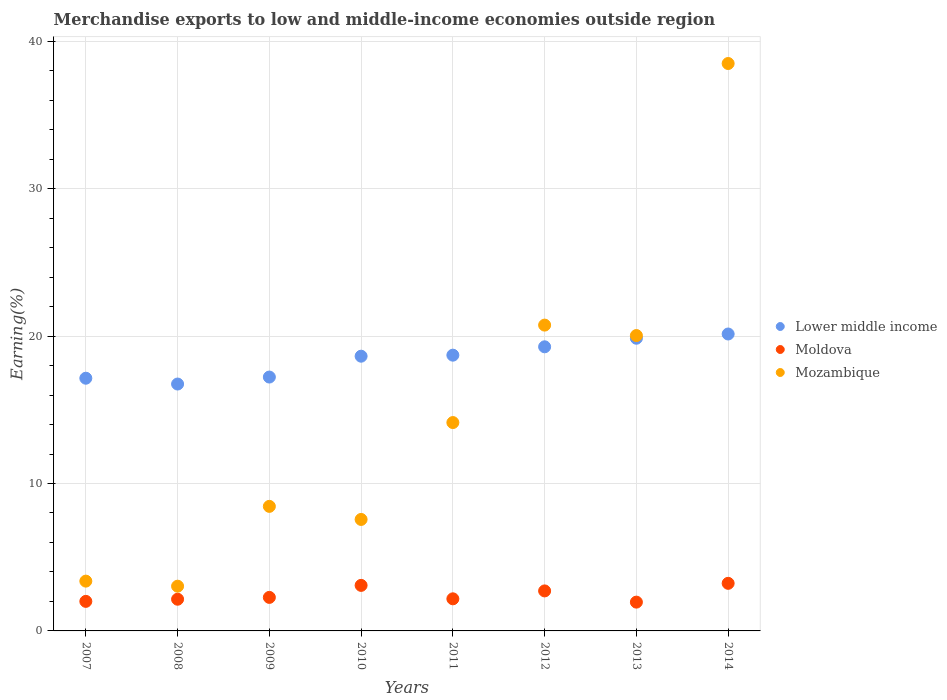How many different coloured dotlines are there?
Your response must be concise. 3. What is the percentage of amount earned from merchandise exports in Moldova in 2013?
Provide a short and direct response. 1.95. Across all years, what is the maximum percentage of amount earned from merchandise exports in Moldova?
Ensure brevity in your answer.  3.23. Across all years, what is the minimum percentage of amount earned from merchandise exports in Moldova?
Your answer should be compact. 1.95. In which year was the percentage of amount earned from merchandise exports in Moldova maximum?
Make the answer very short. 2014. In which year was the percentage of amount earned from merchandise exports in Moldova minimum?
Give a very brief answer. 2013. What is the total percentage of amount earned from merchandise exports in Lower middle income in the graph?
Your answer should be compact. 147.72. What is the difference between the percentage of amount earned from merchandise exports in Lower middle income in 2008 and that in 2014?
Your response must be concise. -3.39. What is the difference between the percentage of amount earned from merchandise exports in Mozambique in 2013 and the percentage of amount earned from merchandise exports in Moldova in 2008?
Provide a short and direct response. 17.89. What is the average percentage of amount earned from merchandise exports in Lower middle income per year?
Keep it short and to the point. 18.47. In the year 2014, what is the difference between the percentage of amount earned from merchandise exports in Lower middle income and percentage of amount earned from merchandise exports in Mozambique?
Make the answer very short. -18.35. In how many years, is the percentage of amount earned from merchandise exports in Lower middle income greater than 12 %?
Provide a short and direct response. 8. What is the ratio of the percentage of amount earned from merchandise exports in Moldova in 2007 to that in 2009?
Provide a short and direct response. 0.88. Is the difference between the percentage of amount earned from merchandise exports in Lower middle income in 2012 and 2013 greater than the difference between the percentage of amount earned from merchandise exports in Mozambique in 2012 and 2013?
Make the answer very short. No. What is the difference between the highest and the second highest percentage of amount earned from merchandise exports in Lower middle income?
Your response must be concise. 0.29. What is the difference between the highest and the lowest percentage of amount earned from merchandise exports in Mozambique?
Keep it short and to the point. 35.46. In how many years, is the percentage of amount earned from merchandise exports in Lower middle income greater than the average percentage of amount earned from merchandise exports in Lower middle income taken over all years?
Your answer should be compact. 5. Does the percentage of amount earned from merchandise exports in Mozambique monotonically increase over the years?
Make the answer very short. No. Is the percentage of amount earned from merchandise exports in Mozambique strictly greater than the percentage of amount earned from merchandise exports in Moldova over the years?
Keep it short and to the point. Yes. Is the percentage of amount earned from merchandise exports in Lower middle income strictly less than the percentage of amount earned from merchandise exports in Moldova over the years?
Provide a succinct answer. No. How many years are there in the graph?
Provide a succinct answer. 8. What is the difference between two consecutive major ticks on the Y-axis?
Your response must be concise. 10. Where does the legend appear in the graph?
Offer a very short reply. Center right. How are the legend labels stacked?
Keep it short and to the point. Vertical. What is the title of the graph?
Give a very brief answer. Merchandise exports to low and middle-income economies outside region. Does "Latin America(all income levels)" appear as one of the legend labels in the graph?
Give a very brief answer. No. What is the label or title of the Y-axis?
Offer a terse response. Earning(%). What is the Earning(%) of Lower middle income in 2007?
Your answer should be very brief. 17.14. What is the Earning(%) in Moldova in 2007?
Offer a very short reply. 2. What is the Earning(%) of Mozambique in 2007?
Your response must be concise. 3.38. What is the Earning(%) of Lower middle income in 2008?
Offer a very short reply. 16.75. What is the Earning(%) in Moldova in 2008?
Your response must be concise. 2.15. What is the Earning(%) of Mozambique in 2008?
Your response must be concise. 3.03. What is the Earning(%) of Lower middle income in 2009?
Make the answer very short. 17.22. What is the Earning(%) in Moldova in 2009?
Give a very brief answer. 2.27. What is the Earning(%) in Mozambique in 2009?
Your answer should be very brief. 8.45. What is the Earning(%) in Lower middle income in 2010?
Provide a short and direct response. 18.64. What is the Earning(%) of Moldova in 2010?
Your answer should be very brief. 3.09. What is the Earning(%) of Mozambique in 2010?
Offer a terse response. 7.56. What is the Earning(%) in Lower middle income in 2011?
Ensure brevity in your answer.  18.71. What is the Earning(%) of Moldova in 2011?
Your response must be concise. 2.18. What is the Earning(%) in Mozambique in 2011?
Ensure brevity in your answer.  14.13. What is the Earning(%) of Lower middle income in 2012?
Your answer should be very brief. 19.27. What is the Earning(%) in Moldova in 2012?
Make the answer very short. 2.71. What is the Earning(%) in Mozambique in 2012?
Provide a short and direct response. 20.74. What is the Earning(%) of Lower middle income in 2013?
Keep it short and to the point. 19.85. What is the Earning(%) of Moldova in 2013?
Give a very brief answer. 1.95. What is the Earning(%) of Mozambique in 2013?
Your answer should be very brief. 20.04. What is the Earning(%) of Lower middle income in 2014?
Your answer should be compact. 20.14. What is the Earning(%) in Moldova in 2014?
Give a very brief answer. 3.23. What is the Earning(%) in Mozambique in 2014?
Offer a very short reply. 38.49. Across all years, what is the maximum Earning(%) in Lower middle income?
Your response must be concise. 20.14. Across all years, what is the maximum Earning(%) of Moldova?
Provide a short and direct response. 3.23. Across all years, what is the maximum Earning(%) of Mozambique?
Give a very brief answer. 38.49. Across all years, what is the minimum Earning(%) of Lower middle income?
Your answer should be compact. 16.75. Across all years, what is the minimum Earning(%) of Moldova?
Provide a succinct answer. 1.95. Across all years, what is the minimum Earning(%) in Mozambique?
Make the answer very short. 3.03. What is the total Earning(%) of Lower middle income in the graph?
Your answer should be very brief. 147.72. What is the total Earning(%) of Moldova in the graph?
Your answer should be compact. 19.59. What is the total Earning(%) in Mozambique in the graph?
Offer a very short reply. 115.83. What is the difference between the Earning(%) of Lower middle income in 2007 and that in 2008?
Give a very brief answer. 0.39. What is the difference between the Earning(%) of Moldova in 2007 and that in 2008?
Offer a very short reply. -0.15. What is the difference between the Earning(%) in Mozambique in 2007 and that in 2008?
Provide a succinct answer. 0.34. What is the difference between the Earning(%) in Lower middle income in 2007 and that in 2009?
Offer a very short reply. -0.08. What is the difference between the Earning(%) of Moldova in 2007 and that in 2009?
Your response must be concise. -0.27. What is the difference between the Earning(%) of Mozambique in 2007 and that in 2009?
Make the answer very short. -5.07. What is the difference between the Earning(%) in Lower middle income in 2007 and that in 2010?
Keep it short and to the point. -1.49. What is the difference between the Earning(%) in Moldova in 2007 and that in 2010?
Ensure brevity in your answer.  -1.08. What is the difference between the Earning(%) in Mozambique in 2007 and that in 2010?
Your answer should be very brief. -4.18. What is the difference between the Earning(%) in Lower middle income in 2007 and that in 2011?
Provide a short and direct response. -1.56. What is the difference between the Earning(%) in Moldova in 2007 and that in 2011?
Ensure brevity in your answer.  -0.17. What is the difference between the Earning(%) of Mozambique in 2007 and that in 2011?
Provide a short and direct response. -10.76. What is the difference between the Earning(%) in Lower middle income in 2007 and that in 2012?
Your response must be concise. -2.13. What is the difference between the Earning(%) of Moldova in 2007 and that in 2012?
Keep it short and to the point. -0.71. What is the difference between the Earning(%) of Mozambique in 2007 and that in 2012?
Provide a short and direct response. -17.37. What is the difference between the Earning(%) of Lower middle income in 2007 and that in 2013?
Make the answer very short. -2.71. What is the difference between the Earning(%) of Moldova in 2007 and that in 2013?
Your response must be concise. 0.05. What is the difference between the Earning(%) of Mozambique in 2007 and that in 2013?
Offer a terse response. -16.66. What is the difference between the Earning(%) of Lower middle income in 2007 and that in 2014?
Keep it short and to the point. -3. What is the difference between the Earning(%) in Moldova in 2007 and that in 2014?
Provide a short and direct response. -1.22. What is the difference between the Earning(%) in Mozambique in 2007 and that in 2014?
Make the answer very short. -35.11. What is the difference between the Earning(%) in Lower middle income in 2008 and that in 2009?
Your answer should be very brief. -0.47. What is the difference between the Earning(%) in Moldova in 2008 and that in 2009?
Give a very brief answer. -0.12. What is the difference between the Earning(%) of Mozambique in 2008 and that in 2009?
Give a very brief answer. -5.41. What is the difference between the Earning(%) of Lower middle income in 2008 and that in 2010?
Provide a succinct answer. -1.89. What is the difference between the Earning(%) in Moldova in 2008 and that in 2010?
Keep it short and to the point. -0.94. What is the difference between the Earning(%) of Mozambique in 2008 and that in 2010?
Offer a very short reply. -4.53. What is the difference between the Earning(%) of Lower middle income in 2008 and that in 2011?
Your answer should be very brief. -1.96. What is the difference between the Earning(%) of Moldova in 2008 and that in 2011?
Keep it short and to the point. -0.03. What is the difference between the Earning(%) of Mozambique in 2008 and that in 2011?
Offer a terse response. -11.1. What is the difference between the Earning(%) of Lower middle income in 2008 and that in 2012?
Your answer should be very brief. -2.53. What is the difference between the Earning(%) of Moldova in 2008 and that in 2012?
Offer a very short reply. -0.56. What is the difference between the Earning(%) of Mozambique in 2008 and that in 2012?
Ensure brevity in your answer.  -17.71. What is the difference between the Earning(%) in Lower middle income in 2008 and that in 2013?
Your response must be concise. -3.11. What is the difference between the Earning(%) in Moldova in 2008 and that in 2013?
Provide a short and direct response. 0.2. What is the difference between the Earning(%) in Mozambique in 2008 and that in 2013?
Provide a succinct answer. -17. What is the difference between the Earning(%) in Lower middle income in 2008 and that in 2014?
Provide a succinct answer. -3.39. What is the difference between the Earning(%) in Moldova in 2008 and that in 2014?
Your answer should be very brief. -1.08. What is the difference between the Earning(%) of Mozambique in 2008 and that in 2014?
Your answer should be very brief. -35.46. What is the difference between the Earning(%) of Lower middle income in 2009 and that in 2010?
Your answer should be compact. -1.41. What is the difference between the Earning(%) in Moldova in 2009 and that in 2010?
Your answer should be compact. -0.81. What is the difference between the Earning(%) in Mozambique in 2009 and that in 2010?
Your answer should be compact. 0.89. What is the difference between the Earning(%) of Lower middle income in 2009 and that in 2011?
Make the answer very short. -1.48. What is the difference between the Earning(%) of Moldova in 2009 and that in 2011?
Provide a succinct answer. 0.1. What is the difference between the Earning(%) of Mozambique in 2009 and that in 2011?
Keep it short and to the point. -5.69. What is the difference between the Earning(%) in Lower middle income in 2009 and that in 2012?
Provide a short and direct response. -2.05. What is the difference between the Earning(%) of Moldova in 2009 and that in 2012?
Ensure brevity in your answer.  -0.44. What is the difference between the Earning(%) in Mozambique in 2009 and that in 2012?
Offer a very short reply. -12.3. What is the difference between the Earning(%) of Lower middle income in 2009 and that in 2013?
Your answer should be compact. -2.63. What is the difference between the Earning(%) of Moldova in 2009 and that in 2013?
Give a very brief answer. 0.32. What is the difference between the Earning(%) of Mozambique in 2009 and that in 2013?
Keep it short and to the point. -11.59. What is the difference between the Earning(%) in Lower middle income in 2009 and that in 2014?
Make the answer very short. -2.92. What is the difference between the Earning(%) in Moldova in 2009 and that in 2014?
Your answer should be compact. -0.95. What is the difference between the Earning(%) of Mozambique in 2009 and that in 2014?
Provide a succinct answer. -30.04. What is the difference between the Earning(%) in Lower middle income in 2010 and that in 2011?
Provide a short and direct response. -0.07. What is the difference between the Earning(%) in Moldova in 2010 and that in 2011?
Offer a very short reply. 0.91. What is the difference between the Earning(%) in Mozambique in 2010 and that in 2011?
Provide a succinct answer. -6.57. What is the difference between the Earning(%) of Lower middle income in 2010 and that in 2012?
Offer a very short reply. -0.64. What is the difference between the Earning(%) of Mozambique in 2010 and that in 2012?
Keep it short and to the point. -13.18. What is the difference between the Earning(%) in Lower middle income in 2010 and that in 2013?
Offer a very short reply. -1.22. What is the difference between the Earning(%) in Moldova in 2010 and that in 2013?
Give a very brief answer. 1.14. What is the difference between the Earning(%) of Mozambique in 2010 and that in 2013?
Make the answer very short. -12.47. What is the difference between the Earning(%) in Lower middle income in 2010 and that in 2014?
Your response must be concise. -1.51. What is the difference between the Earning(%) in Moldova in 2010 and that in 2014?
Keep it short and to the point. -0.14. What is the difference between the Earning(%) of Mozambique in 2010 and that in 2014?
Offer a very short reply. -30.93. What is the difference between the Earning(%) of Lower middle income in 2011 and that in 2012?
Offer a very short reply. -0.57. What is the difference between the Earning(%) of Moldova in 2011 and that in 2012?
Offer a very short reply. -0.54. What is the difference between the Earning(%) in Mozambique in 2011 and that in 2012?
Your response must be concise. -6.61. What is the difference between the Earning(%) of Lower middle income in 2011 and that in 2013?
Ensure brevity in your answer.  -1.15. What is the difference between the Earning(%) of Moldova in 2011 and that in 2013?
Offer a very short reply. 0.22. What is the difference between the Earning(%) of Mozambique in 2011 and that in 2013?
Your response must be concise. -5.9. What is the difference between the Earning(%) in Lower middle income in 2011 and that in 2014?
Offer a terse response. -1.44. What is the difference between the Earning(%) of Moldova in 2011 and that in 2014?
Your answer should be compact. -1.05. What is the difference between the Earning(%) of Mozambique in 2011 and that in 2014?
Offer a very short reply. -24.36. What is the difference between the Earning(%) in Lower middle income in 2012 and that in 2013?
Your answer should be compact. -0.58. What is the difference between the Earning(%) of Moldova in 2012 and that in 2013?
Offer a terse response. 0.76. What is the difference between the Earning(%) in Mozambique in 2012 and that in 2013?
Your response must be concise. 0.71. What is the difference between the Earning(%) of Lower middle income in 2012 and that in 2014?
Make the answer very short. -0.87. What is the difference between the Earning(%) in Moldova in 2012 and that in 2014?
Provide a short and direct response. -0.51. What is the difference between the Earning(%) in Mozambique in 2012 and that in 2014?
Offer a very short reply. -17.75. What is the difference between the Earning(%) of Lower middle income in 2013 and that in 2014?
Provide a short and direct response. -0.29. What is the difference between the Earning(%) in Moldova in 2013 and that in 2014?
Make the answer very short. -1.28. What is the difference between the Earning(%) in Mozambique in 2013 and that in 2014?
Provide a short and direct response. -18.45. What is the difference between the Earning(%) in Lower middle income in 2007 and the Earning(%) in Moldova in 2008?
Keep it short and to the point. 14.99. What is the difference between the Earning(%) of Lower middle income in 2007 and the Earning(%) of Mozambique in 2008?
Offer a very short reply. 14.11. What is the difference between the Earning(%) in Moldova in 2007 and the Earning(%) in Mozambique in 2008?
Make the answer very short. -1.03. What is the difference between the Earning(%) in Lower middle income in 2007 and the Earning(%) in Moldova in 2009?
Your answer should be compact. 14.87. What is the difference between the Earning(%) of Lower middle income in 2007 and the Earning(%) of Mozambique in 2009?
Keep it short and to the point. 8.69. What is the difference between the Earning(%) in Moldova in 2007 and the Earning(%) in Mozambique in 2009?
Your answer should be very brief. -6.44. What is the difference between the Earning(%) of Lower middle income in 2007 and the Earning(%) of Moldova in 2010?
Offer a terse response. 14.05. What is the difference between the Earning(%) of Lower middle income in 2007 and the Earning(%) of Mozambique in 2010?
Your response must be concise. 9.58. What is the difference between the Earning(%) in Moldova in 2007 and the Earning(%) in Mozambique in 2010?
Provide a succinct answer. -5.56. What is the difference between the Earning(%) of Lower middle income in 2007 and the Earning(%) of Moldova in 2011?
Give a very brief answer. 14.96. What is the difference between the Earning(%) of Lower middle income in 2007 and the Earning(%) of Mozambique in 2011?
Offer a very short reply. 3.01. What is the difference between the Earning(%) of Moldova in 2007 and the Earning(%) of Mozambique in 2011?
Give a very brief answer. -12.13. What is the difference between the Earning(%) in Lower middle income in 2007 and the Earning(%) in Moldova in 2012?
Provide a succinct answer. 14.43. What is the difference between the Earning(%) in Lower middle income in 2007 and the Earning(%) in Mozambique in 2012?
Offer a very short reply. -3.6. What is the difference between the Earning(%) in Moldova in 2007 and the Earning(%) in Mozambique in 2012?
Your answer should be compact. -18.74. What is the difference between the Earning(%) of Lower middle income in 2007 and the Earning(%) of Moldova in 2013?
Provide a short and direct response. 15.19. What is the difference between the Earning(%) in Lower middle income in 2007 and the Earning(%) in Mozambique in 2013?
Your response must be concise. -2.89. What is the difference between the Earning(%) in Moldova in 2007 and the Earning(%) in Mozambique in 2013?
Offer a terse response. -18.03. What is the difference between the Earning(%) in Lower middle income in 2007 and the Earning(%) in Moldova in 2014?
Keep it short and to the point. 13.91. What is the difference between the Earning(%) of Lower middle income in 2007 and the Earning(%) of Mozambique in 2014?
Your response must be concise. -21.35. What is the difference between the Earning(%) of Moldova in 2007 and the Earning(%) of Mozambique in 2014?
Your answer should be very brief. -36.49. What is the difference between the Earning(%) of Lower middle income in 2008 and the Earning(%) of Moldova in 2009?
Offer a very short reply. 14.47. What is the difference between the Earning(%) of Lower middle income in 2008 and the Earning(%) of Mozambique in 2009?
Give a very brief answer. 8.3. What is the difference between the Earning(%) in Moldova in 2008 and the Earning(%) in Mozambique in 2009?
Provide a short and direct response. -6.3. What is the difference between the Earning(%) in Lower middle income in 2008 and the Earning(%) in Moldova in 2010?
Keep it short and to the point. 13.66. What is the difference between the Earning(%) in Lower middle income in 2008 and the Earning(%) in Mozambique in 2010?
Your response must be concise. 9.19. What is the difference between the Earning(%) in Moldova in 2008 and the Earning(%) in Mozambique in 2010?
Give a very brief answer. -5.41. What is the difference between the Earning(%) of Lower middle income in 2008 and the Earning(%) of Moldova in 2011?
Offer a very short reply. 14.57. What is the difference between the Earning(%) in Lower middle income in 2008 and the Earning(%) in Mozambique in 2011?
Provide a short and direct response. 2.61. What is the difference between the Earning(%) of Moldova in 2008 and the Earning(%) of Mozambique in 2011?
Your answer should be very brief. -11.98. What is the difference between the Earning(%) in Lower middle income in 2008 and the Earning(%) in Moldova in 2012?
Make the answer very short. 14.03. What is the difference between the Earning(%) of Lower middle income in 2008 and the Earning(%) of Mozambique in 2012?
Provide a short and direct response. -4. What is the difference between the Earning(%) of Moldova in 2008 and the Earning(%) of Mozambique in 2012?
Your answer should be compact. -18.59. What is the difference between the Earning(%) in Lower middle income in 2008 and the Earning(%) in Moldova in 2013?
Your answer should be very brief. 14.79. What is the difference between the Earning(%) in Lower middle income in 2008 and the Earning(%) in Mozambique in 2013?
Ensure brevity in your answer.  -3.29. What is the difference between the Earning(%) in Moldova in 2008 and the Earning(%) in Mozambique in 2013?
Your answer should be compact. -17.89. What is the difference between the Earning(%) of Lower middle income in 2008 and the Earning(%) of Moldova in 2014?
Your answer should be compact. 13.52. What is the difference between the Earning(%) in Lower middle income in 2008 and the Earning(%) in Mozambique in 2014?
Give a very brief answer. -21.74. What is the difference between the Earning(%) in Moldova in 2008 and the Earning(%) in Mozambique in 2014?
Keep it short and to the point. -36.34. What is the difference between the Earning(%) in Lower middle income in 2009 and the Earning(%) in Moldova in 2010?
Make the answer very short. 14.13. What is the difference between the Earning(%) of Lower middle income in 2009 and the Earning(%) of Mozambique in 2010?
Offer a terse response. 9.66. What is the difference between the Earning(%) of Moldova in 2009 and the Earning(%) of Mozambique in 2010?
Your answer should be compact. -5.29. What is the difference between the Earning(%) of Lower middle income in 2009 and the Earning(%) of Moldova in 2011?
Your answer should be very brief. 15.04. What is the difference between the Earning(%) in Lower middle income in 2009 and the Earning(%) in Mozambique in 2011?
Give a very brief answer. 3.09. What is the difference between the Earning(%) in Moldova in 2009 and the Earning(%) in Mozambique in 2011?
Your answer should be compact. -11.86. What is the difference between the Earning(%) in Lower middle income in 2009 and the Earning(%) in Moldova in 2012?
Offer a terse response. 14.51. What is the difference between the Earning(%) of Lower middle income in 2009 and the Earning(%) of Mozambique in 2012?
Your answer should be compact. -3.52. What is the difference between the Earning(%) of Moldova in 2009 and the Earning(%) of Mozambique in 2012?
Give a very brief answer. -18.47. What is the difference between the Earning(%) of Lower middle income in 2009 and the Earning(%) of Moldova in 2013?
Your answer should be very brief. 15.27. What is the difference between the Earning(%) in Lower middle income in 2009 and the Earning(%) in Mozambique in 2013?
Ensure brevity in your answer.  -2.82. What is the difference between the Earning(%) in Moldova in 2009 and the Earning(%) in Mozambique in 2013?
Keep it short and to the point. -17.76. What is the difference between the Earning(%) of Lower middle income in 2009 and the Earning(%) of Moldova in 2014?
Ensure brevity in your answer.  13.99. What is the difference between the Earning(%) of Lower middle income in 2009 and the Earning(%) of Mozambique in 2014?
Give a very brief answer. -21.27. What is the difference between the Earning(%) of Moldova in 2009 and the Earning(%) of Mozambique in 2014?
Offer a terse response. -36.22. What is the difference between the Earning(%) in Lower middle income in 2010 and the Earning(%) in Moldova in 2011?
Offer a very short reply. 16.46. What is the difference between the Earning(%) of Lower middle income in 2010 and the Earning(%) of Mozambique in 2011?
Provide a succinct answer. 4.5. What is the difference between the Earning(%) of Moldova in 2010 and the Earning(%) of Mozambique in 2011?
Your response must be concise. -11.05. What is the difference between the Earning(%) of Lower middle income in 2010 and the Earning(%) of Moldova in 2012?
Provide a succinct answer. 15.92. What is the difference between the Earning(%) in Lower middle income in 2010 and the Earning(%) in Mozambique in 2012?
Ensure brevity in your answer.  -2.11. What is the difference between the Earning(%) of Moldova in 2010 and the Earning(%) of Mozambique in 2012?
Your response must be concise. -17.66. What is the difference between the Earning(%) in Lower middle income in 2010 and the Earning(%) in Moldova in 2013?
Provide a short and direct response. 16.68. What is the difference between the Earning(%) of Lower middle income in 2010 and the Earning(%) of Mozambique in 2013?
Provide a succinct answer. -1.4. What is the difference between the Earning(%) in Moldova in 2010 and the Earning(%) in Mozambique in 2013?
Offer a terse response. -16.95. What is the difference between the Earning(%) in Lower middle income in 2010 and the Earning(%) in Moldova in 2014?
Your answer should be very brief. 15.41. What is the difference between the Earning(%) of Lower middle income in 2010 and the Earning(%) of Mozambique in 2014?
Offer a very short reply. -19.85. What is the difference between the Earning(%) in Moldova in 2010 and the Earning(%) in Mozambique in 2014?
Provide a succinct answer. -35.4. What is the difference between the Earning(%) in Lower middle income in 2011 and the Earning(%) in Moldova in 2012?
Provide a short and direct response. 15.99. What is the difference between the Earning(%) of Lower middle income in 2011 and the Earning(%) of Mozambique in 2012?
Your answer should be compact. -2.04. What is the difference between the Earning(%) in Moldova in 2011 and the Earning(%) in Mozambique in 2012?
Your answer should be very brief. -18.57. What is the difference between the Earning(%) of Lower middle income in 2011 and the Earning(%) of Moldova in 2013?
Offer a very short reply. 16.75. What is the difference between the Earning(%) of Lower middle income in 2011 and the Earning(%) of Mozambique in 2013?
Provide a succinct answer. -1.33. What is the difference between the Earning(%) of Moldova in 2011 and the Earning(%) of Mozambique in 2013?
Offer a very short reply. -17.86. What is the difference between the Earning(%) of Lower middle income in 2011 and the Earning(%) of Moldova in 2014?
Give a very brief answer. 15.48. What is the difference between the Earning(%) of Lower middle income in 2011 and the Earning(%) of Mozambique in 2014?
Offer a terse response. -19.78. What is the difference between the Earning(%) in Moldova in 2011 and the Earning(%) in Mozambique in 2014?
Make the answer very short. -36.31. What is the difference between the Earning(%) in Lower middle income in 2012 and the Earning(%) in Moldova in 2013?
Keep it short and to the point. 17.32. What is the difference between the Earning(%) in Lower middle income in 2012 and the Earning(%) in Mozambique in 2013?
Your answer should be compact. -0.76. What is the difference between the Earning(%) in Moldova in 2012 and the Earning(%) in Mozambique in 2013?
Offer a terse response. -17.32. What is the difference between the Earning(%) in Lower middle income in 2012 and the Earning(%) in Moldova in 2014?
Offer a very short reply. 16.04. What is the difference between the Earning(%) in Lower middle income in 2012 and the Earning(%) in Mozambique in 2014?
Give a very brief answer. -19.22. What is the difference between the Earning(%) of Moldova in 2012 and the Earning(%) of Mozambique in 2014?
Provide a succinct answer. -35.78. What is the difference between the Earning(%) of Lower middle income in 2013 and the Earning(%) of Moldova in 2014?
Your answer should be very brief. 16.63. What is the difference between the Earning(%) of Lower middle income in 2013 and the Earning(%) of Mozambique in 2014?
Give a very brief answer. -18.64. What is the difference between the Earning(%) of Moldova in 2013 and the Earning(%) of Mozambique in 2014?
Keep it short and to the point. -36.54. What is the average Earning(%) in Lower middle income per year?
Your response must be concise. 18.47. What is the average Earning(%) of Moldova per year?
Provide a succinct answer. 2.45. What is the average Earning(%) of Mozambique per year?
Your answer should be compact. 14.48. In the year 2007, what is the difference between the Earning(%) in Lower middle income and Earning(%) in Moldova?
Make the answer very short. 15.14. In the year 2007, what is the difference between the Earning(%) in Lower middle income and Earning(%) in Mozambique?
Keep it short and to the point. 13.76. In the year 2007, what is the difference between the Earning(%) in Moldova and Earning(%) in Mozambique?
Ensure brevity in your answer.  -1.37. In the year 2008, what is the difference between the Earning(%) in Lower middle income and Earning(%) in Moldova?
Offer a very short reply. 14.6. In the year 2008, what is the difference between the Earning(%) in Lower middle income and Earning(%) in Mozambique?
Provide a succinct answer. 13.71. In the year 2008, what is the difference between the Earning(%) of Moldova and Earning(%) of Mozambique?
Your answer should be very brief. -0.88. In the year 2009, what is the difference between the Earning(%) in Lower middle income and Earning(%) in Moldova?
Provide a succinct answer. 14.95. In the year 2009, what is the difference between the Earning(%) in Lower middle income and Earning(%) in Mozambique?
Give a very brief answer. 8.77. In the year 2009, what is the difference between the Earning(%) of Moldova and Earning(%) of Mozambique?
Give a very brief answer. -6.17. In the year 2010, what is the difference between the Earning(%) in Lower middle income and Earning(%) in Moldova?
Your response must be concise. 15.55. In the year 2010, what is the difference between the Earning(%) of Lower middle income and Earning(%) of Mozambique?
Ensure brevity in your answer.  11.07. In the year 2010, what is the difference between the Earning(%) in Moldova and Earning(%) in Mozambique?
Provide a short and direct response. -4.47. In the year 2011, what is the difference between the Earning(%) of Lower middle income and Earning(%) of Moldova?
Provide a short and direct response. 16.53. In the year 2011, what is the difference between the Earning(%) of Lower middle income and Earning(%) of Mozambique?
Give a very brief answer. 4.57. In the year 2011, what is the difference between the Earning(%) in Moldova and Earning(%) in Mozambique?
Your answer should be compact. -11.96. In the year 2012, what is the difference between the Earning(%) in Lower middle income and Earning(%) in Moldova?
Offer a terse response. 16.56. In the year 2012, what is the difference between the Earning(%) in Lower middle income and Earning(%) in Mozambique?
Ensure brevity in your answer.  -1.47. In the year 2012, what is the difference between the Earning(%) in Moldova and Earning(%) in Mozambique?
Your response must be concise. -18.03. In the year 2013, what is the difference between the Earning(%) in Lower middle income and Earning(%) in Moldova?
Your answer should be compact. 17.9. In the year 2013, what is the difference between the Earning(%) of Lower middle income and Earning(%) of Mozambique?
Make the answer very short. -0.18. In the year 2013, what is the difference between the Earning(%) in Moldova and Earning(%) in Mozambique?
Provide a short and direct response. -18.08. In the year 2014, what is the difference between the Earning(%) of Lower middle income and Earning(%) of Moldova?
Offer a terse response. 16.91. In the year 2014, what is the difference between the Earning(%) in Lower middle income and Earning(%) in Mozambique?
Offer a very short reply. -18.35. In the year 2014, what is the difference between the Earning(%) of Moldova and Earning(%) of Mozambique?
Keep it short and to the point. -35.26. What is the ratio of the Earning(%) in Lower middle income in 2007 to that in 2008?
Give a very brief answer. 1.02. What is the ratio of the Earning(%) in Moldova in 2007 to that in 2008?
Ensure brevity in your answer.  0.93. What is the ratio of the Earning(%) in Mozambique in 2007 to that in 2008?
Provide a short and direct response. 1.11. What is the ratio of the Earning(%) in Lower middle income in 2007 to that in 2009?
Provide a short and direct response. 1. What is the ratio of the Earning(%) of Moldova in 2007 to that in 2009?
Your answer should be compact. 0.88. What is the ratio of the Earning(%) in Mozambique in 2007 to that in 2009?
Provide a succinct answer. 0.4. What is the ratio of the Earning(%) in Lower middle income in 2007 to that in 2010?
Your answer should be compact. 0.92. What is the ratio of the Earning(%) in Moldova in 2007 to that in 2010?
Keep it short and to the point. 0.65. What is the ratio of the Earning(%) in Mozambique in 2007 to that in 2010?
Keep it short and to the point. 0.45. What is the ratio of the Earning(%) of Lower middle income in 2007 to that in 2011?
Your response must be concise. 0.92. What is the ratio of the Earning(%) of Moldova in 2007 to that in 2011?
Provide a succinct answer. 0.92. What is the ratio of the Earning(%) of Mozambique in 2007 to that in 2011?
Offer a very short reply. 0.24. What is the ratio of the Earning(%) in Lower middle income in 2007 to that in 2012?
Provide a short and direct response. 0.89. What is the ratio of the Earning(%) in Moldova in 2007 to that in 2012?
Provide a succinct answer. 0.74. What is the ratio of the Earning(%) in Mozambique in 2007 to that in 2012?
Ensure brevity in your answer.  0.16. What is the ratio of the Earning(%) in Lower middle income in 2007 to that in 2013?
Provide a succinct answer. 0.86. What is the ratio of the Earning(%) in Moldova in 2007 to that in 2013?
Offer a very short reply. 1.03. What is the ratio of the Earning(%) in Mozambique in 2007 to that in 2013?
Ensure brevity in your answer.  0.17. What is the ratio of the Earning(%) in Lower middle income in 2007 to that in 2014?
Provide a succinct answer. 0.85. What is the ratio of the Earning(%) of Moldova in 2007 to that in 2014?
Offer a very short reply. 0.62. What is the ratio of the Earning(%) of Mozambique in 2007 to that in 2014?
Make the answer very short. 0.09. What is the ratio of the Earning(%) in Lower middle income in 2008 to that in 2009?
Your answer should be very brief. 0.97. What is the ratio of the Earning(%) in Moldova in 2008 to that in 2009?
Provide a succinct answer. 0.95. What is the ratio of the Earning(%) in Mozambique in 2008 to that in 2009?
Make the answer very short. 0.36. What is the ratio of the Earning(%) in Lower middle income in 2008 to that in 2010?
Ensure brevity in your answer.  0.9. What is the ratio of the Earning(%) in Moldova in 2008 to that in 2010?
Your answer should be compact. 0.7. What is the ratio of the Earning(%) of Mozambique in 2008 to that in 2010?
Your answer should be compact. 0.4. What is the ratio of the Earning(%) in Lower middle income in 2008 to that in 2011?
Keep it short and to the point. 0.9. What is the ratio of the Earning(%) in Moldova in 2008 to that in 2011?
Offer a terse response. 0.99. What is the ratio of the Earning(%) of Mozambique in 2008 to that in 2011?
Offer a very short reply. 0.21. What is the ratio of the Earning(%) in Lower middle income in 2008 to that in 2012?
Keep it short and to the point. 0.87. What is the ratio of the Earning(%) in Moldova in 2008 to that in 2012?
Make the answer very short. 0.79. What is the ratio of the Earning(%) of Mozambique in 2008 to that in 2012?
Offer a terse response. 0.15. What is the ratio of the Earning(%) of Lower middle income in 2008 to that in 2013?
Keep it short and to the point. 0.84. What is the ratio of the Earning(%) in Moldova in 2008 to that in 2013?
Provide a succinct answer. 1.1. What is the ratio of the Earning(%) in Mozambique in 2008 to that in 2013?
Your response must be concise. 0.15. What is the ratio of the Earning(%) of Lower middle income in 2008 to that in 2014?
Your answer should be very brief. 0.83. What is the ratio of the Earning(%) of Moldova in 2008 to that in 2014?
Your answer should be very brief. 0.67. What is the ratio of the Earning(%) of Mozambique in 2008 to that in 2014?
Provide a short and direct response. 0.08. What is the ratio of the Earning(%) of Lower middle income in 2009 to that in 2010?
Your response must be concise. 0.92. What is the ratio of the Earning(%) of Moldova in 2009 to that in 2010?
Give a very brief answer. 0.74. What is the ratio of the Earning(%) in Mozambique in 2009 to that in 2010?
Ensure brevity in your answer.  1.12. What is the ratio of the Earning(%) of Lower middle income in 2009 to that in 2011?
Give a very brief answer. 0.92. What is the ratio of the Earning(%) in Moldova in 2009 to that in 2011?
Offer a very short reply. 1.04. What is the ratio of the Earning(%) of Mozambique in 2009 to that in 2011?
Your response must be concise. 0.6. What is the ratio of the Earning(%) in Lower middle income in 2009 to that in 2012?
Provide a short and direct response. 0.89. What is the ratio of the Earning(%) of Moldova in 2009 to that in 2012?
Provide a short and direct response. 0.84. What is the ratio of the Earning(%) of Mozambique in 2009 to that in 2012?
Your answer should be compact. 0.41. What is the ratio of the Earning(%) of Lower middle income in 2009 to that in 2013?
Your answer should be very brief. 0.87. What is the ratio of the Earning(%) in Moldova in 2009 to that in 2013?
Make the answer very short. 1.16. What is the ratio of the Earning(%) of Mozambique in 2009 to that in 2013?
Keep it short and to the point. 0.42. What is the ratio of the Earning(%) in Lower middle income in 2009 to that in 2014?
Ensure brevity in your answer.  0.85. What is the ratio of the Earning(%) in Moldova in 2009 to that in 2014?
Your response must be concise. 0.7. What is the ratio of the Earning(%) of Mozambique in 2009 to that in 2014?
Provide a succinct answer. 0.22. What is the ratio of the Earning(%) of Moldova in 2010 to that in 2011?
Provide a short and direct response. 1.42. What is the ratio of the Earning(%) in Mozambique in 2010 to that in 2011?
Provide a short and direct response. 0.54. What is the ratio of the Earning(%) in Lower middle income in 2010 to that in 2012?
Ensure brevity in your answer.  0.97. What is the ratio of the Earning(%) in Moldova in 2010 to that in 2012?
Keep it short and to the point. 1.14. What is the ratio of the Earning(%) in Mozambique in 2010 to that in 2012?
Your answer should be very brief. 0.36. What is the ratio of the Earning(%) in Lower middle income in 2010 to that in 2013?
Provide a short and direct response. 0.94. What is the ratio of the Earning(%) in Moldova in 2010 to that in 2013?
Provide a succinct answer. 1.58. What is the ratio of the Earning(%) of Mozambique in 2010 to that in 2013?
Offer a very short reply. 0.38. What is the ratio of the Earning(%) in Lower middle income in 2010 to that in 2014?
Offer a terse response. 0.93. What is the ratio of the Earning(%) of Moldova in 2010 to that in 2014?
Keep it short and to the point. 0.96. What is the ratio of the Earning(%) in Mozambique in 2010 to that in 2014?
Ensure brevity in your answer.  0.2. What is the ratio of the Earning(%) of Lower middle income in 2011 to that in 2012?
Ensure brevity in your answer.  0.97. What is the ratio of the Earning(%) of Moldova in 2011 to that in 2012?
Offer a very short reply. 0.8. What is the ratio of the Earning(%) of Mozambique in 2011 to that in 2012?
Provide a short and direct response. 0.68. What is the ratio of the Earning(%) of Lower middle income in 2011 to that in 2013?
Make the answer very short. 0.94. What is the ratio of the Earning(%) in Moldova in 2011 to that in 2013?
Your answer should be compact. 1.12. What is the ratio of the Earning(%) in Mozambique in 2011 to that in 2013?
Your answer should be very brief. 0.71. What is the ratio of the Earning(%) of Lower middle income in 2011 to that in 2014?
Keep it short and to the point. 0.93. What is the ratio of the Earning(%) of Moldova in 2011 to that in 2014?
Offer a very short reply. 0.67. What is the ratio of the Earning(%) of Mozambique in 2011 to that in 2014?
Make the answer very short. 0.37. What is the ratio of the Earning(%) in Lower middle income in 2012 to that in 2013?
Your answer should be compact. 0.97. What is the ratio of the Earning(%) in Moldova in 2012 to that in 2013?
Offer a very short reply. 1.39. What is the ratio of the Earning(%) in Mozambique in 2012 to that in 2013?
Offer a very short reply. 1.04. What is the ratio of the Earning(%) in Lower middle income in 2012 to that in 2014?
Keep it short and to the point. 0.96. What is the ratio of the Earning(%) of Moldova in 2012 to that in 2014?
Provide a succinct answer. 0.84. What is the ratio of the Earning(%) of Mozambique in 2012 to that in 2014?
Make the answer very short. 0.54. What is the ratio of the Earning(%) of Lower middle income in 2013 to that in 2014?
Provide a succinct answer. 0.99. What is the ratio of the Earning(%) of Moldova in 2013 to that in 2014?
Your answer should be compact. 0.6. What is the ratio of the Earning(%) of Mozambique in 2013 to that in 2014?
Keep it short and to the point. 0.52. What is the difference between the highest and the second highest Earning(%) in Lower middle income?
Your answer should be compact. 0.29. What is the difference between the highest and the second highest Earning(%) in Moldova?
Provide a short and direct response. 0.14. What is the difference between the highest and the second highest Earning(%) of Mozambique?
Your response must be concise. 17.75. What is the difference between the highest and the lowest Earning(%) of Lower middle income?
Provide a short and direct response. 3.39. What is the difference between the highest and the lowest Earning(%) of Moldova?
Ensure brevity in your answer.  1.28. What is the difference between the highest and the lowest Earning(%) of Mozambique?
Make the answer very short. 35.46. 